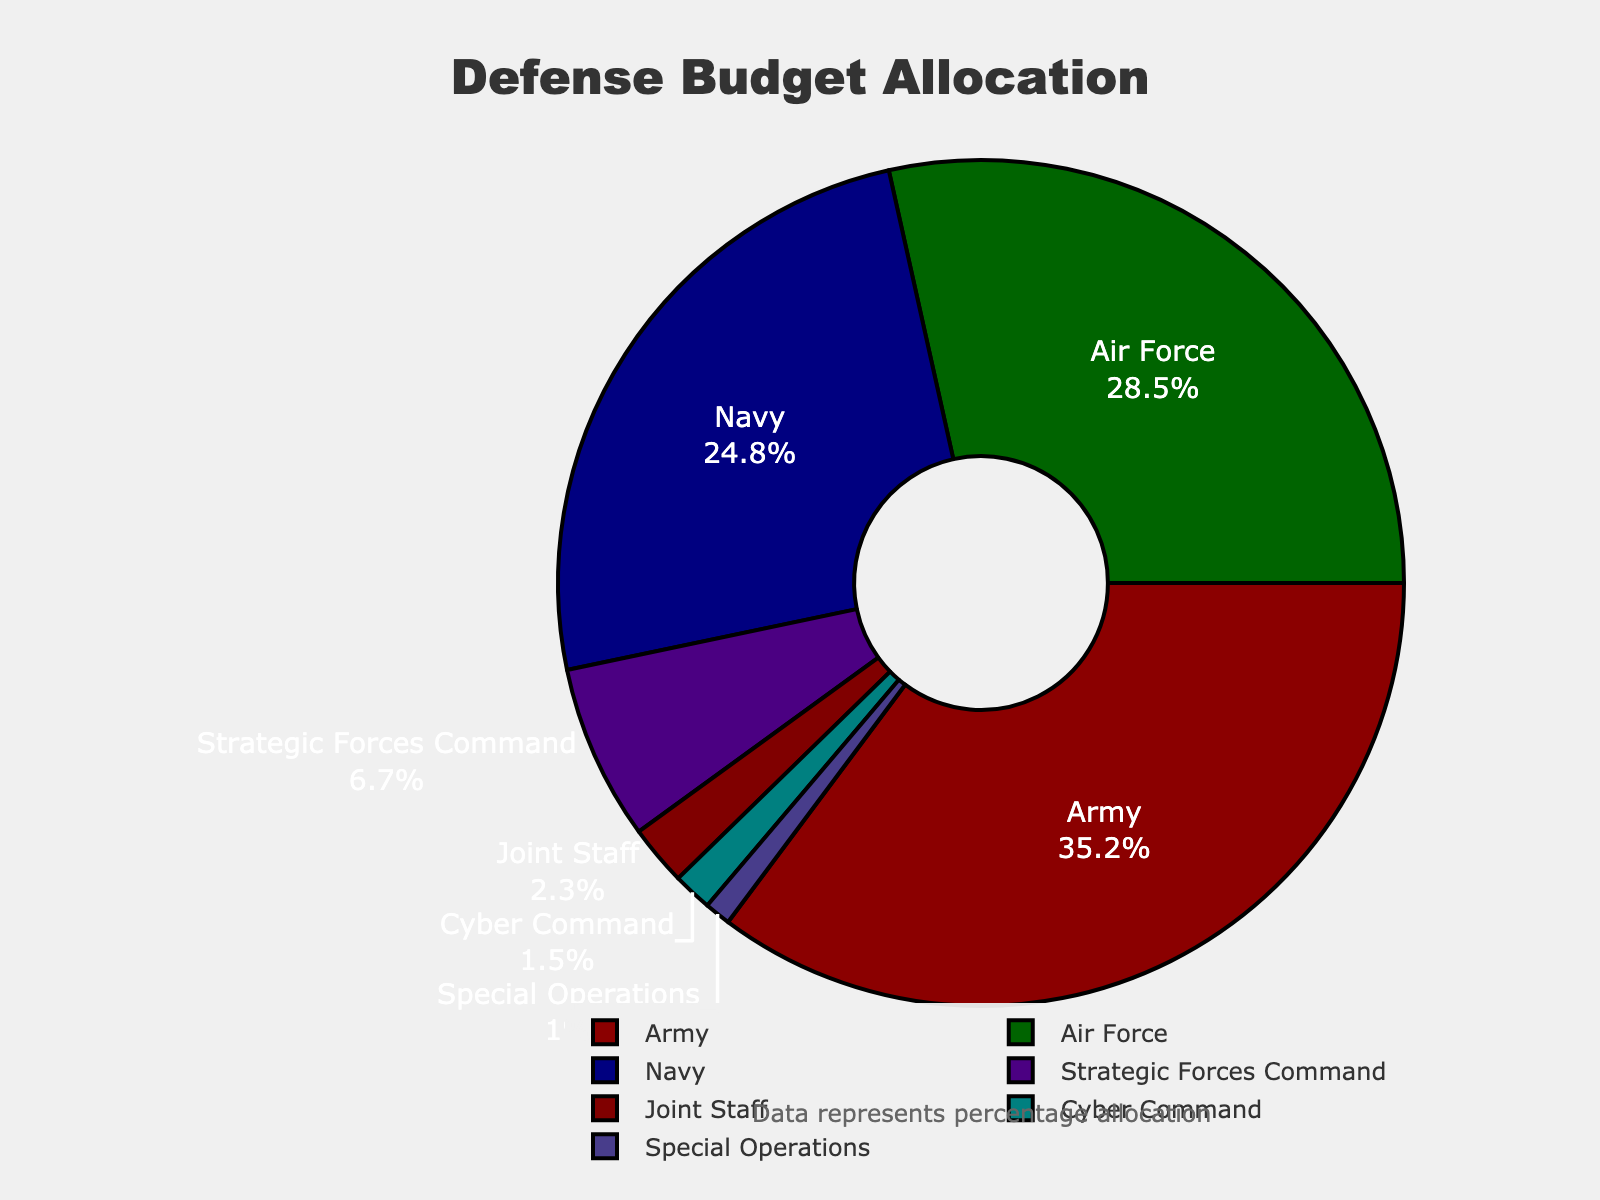What percentage of the budget is allocated to Special Operations and Cyber Command combined? The percentage allocated to Special Operations is 1.0%, and for Cyber Command, it is 1.5%. Adding these together gives 1.0% + 1.5% = 2.5%.
Answer: 2.5% Which branch receives the highest percentage of the defense budget? By reviewing the percentages allocated to each branch, the Army receives the highest percentage at 35.2%.
Answer: Army How much more of the budget is allocated to the Army compared to the Navy? The Army receives 35.2% of the budget, while the Navy receives 24.8%. The difference is 35.2% - 24.8% = 10.4%.
Answer: 10.4% What is the ratio of the budget allocated to the Air Force to that allocated to the Navy? The percentage for the Air Force is 28.5%, and for the Navy, it is 24.8%. The ratio is 28.5% / 24.8% ≈ 1.15.
Answer: 1.15 Which branches receive less than 3% of the defense budget? The branches receiving less than 3% are the Joint Staff (2.3%), Cyber Command (1.5%), and Special Operations (1.0%).
Answer: Joint Staff, Cyber Command, Special Operations If the total budget is $500 billion, how much is allocated to the Strategic Forces Command? The Strategic Forces Command receives 6.7% of the budget. Therefore, the allocation is 6.7% of $500 billion, which is 0.067 * $500 billion = $33.5 billion.
Answer: $33.5 billion By how much does the percentage allocated to the Air Force exceed that allocated to the Strategic Forces Command? The Air Force is allocated 28.5%, while the Strategic Forces Command is allocated 6.7%. The difference is 28.5% - 6.7% = 21.8%.
Answer: 21.8% Which branches together account for over half of the defense budget? The branches and their percentages are: Army (35.2%), Navy (24.8%), Air Force (28.5%), Strategic Forces Command (6.7%), Joint Staff (2.3%), Cyber Command (1.5%), and Special Operations (1.0%). Combining the top three: Army (35.2%) + Navy (24.8%) + Air Force (28.5%) = 88.5%, which is well over 50%.
Answer: Army, Navy, Air Force 